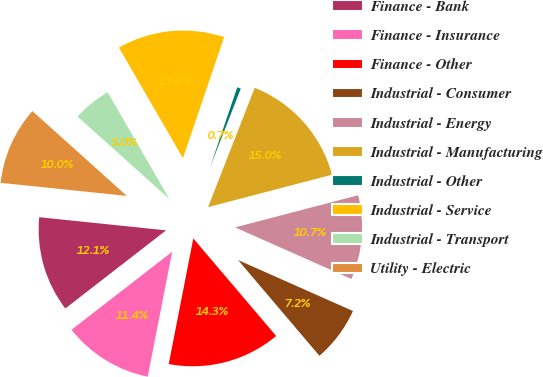<chart> <loc_0><loc_0><loc_500><loc_500><pie_chart><fcel>Finance - Bank<fcel>Finance - Insurance<fcel>Finance - Other<fcel>Industrial - Consumer<fcel>Industrial - Energy<fcel>Industrial - Manufacturing<fcel>Industrial - Other<fcel>Industrial - Service<fcel>Industrial - Transport<fcel>Utility - Electric<nl><fcel>12.14%<fcel>11.43%<fcel>14.28%<fcel>7.15%<fcel>10.71%<fcel>15.0%<fcel>0.72%<fcel>13.57%<fcel>5.0%<fcel>10.0%<nl></chart> 